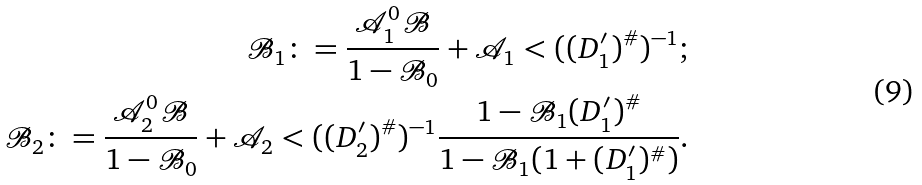<formula> <loc_0><loc_0><loc_500><loc_500>\mathcal { B } _ { 1 } \colon = \frac { \mathcal { A } _ { 1 } ^ { 0 } \mathcal { B } } { 1 - \mathcal { B } _ { 0 } } + \mathcal { A } _ { 1 } < ( ( D _ { 1 } ^ { \prime } ) ^ { \# } ) ^ { - 1 } ; \\ \mathcal { B } _ { 2 } \colon = \frac { \mathcal { A } _ { 2 } ^ { 0 } \mathcal { B } } { 1 - \mathcal { B } _ { 0 } } + \mathcal { A } _ { 2 } < ( ( D _ { 2 } ^ { \prime } ) ^ { \# } ) ^ { - 1 } \frac { 1 - \mathcal { B } _ { 1 } ( D _ { 1 } ^ { \prime } ) ^ { \# } } { 1 - \mathcal { B } _ { 1 } ( 1 + ( D _ { 1 } ^ { \prime } ) ^ { \# } ) } .</formula> 